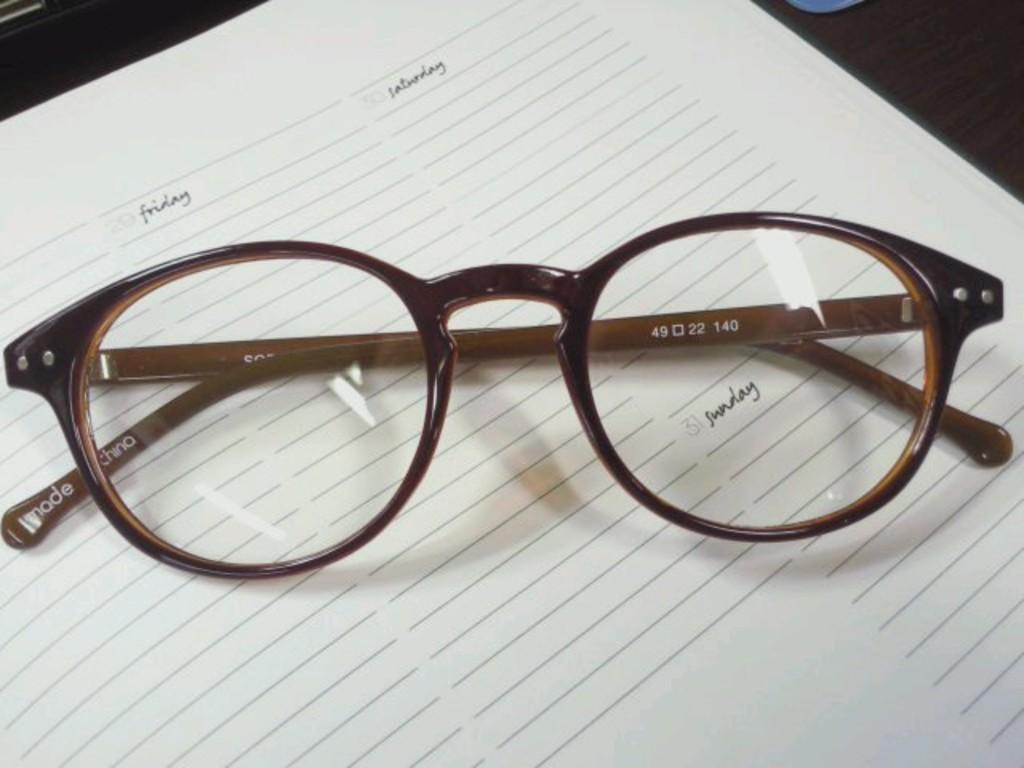What is the main subject of the image? There is a spectacle in the image. How is the spectacle positioned in the image? The spectacle is placed on a paper. What can be seen on the paper besides the spectacle? There is writing on the paper. What is the color of the surface on which the paper is placed? The paper is placed on a black surface. What type of twist can be seen in the image? There is no twist present in the image. Who is the creator of the spectacle in the image? The image does not provide information about the creator of the spectacle. 